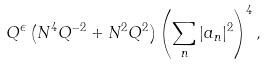Convert formula to latex. <formula><loc_0><loc_0><loc_500><loc_500>Q ^ { \epsilon } \left ( N ^ { 4 } Q ^ { - 2 } + N ^ { 2 } Q ^ { 2 } \right ) \left ( \sum _ { n } | a _ { n } | ^ { 2 } \right ) ^ { 4 } ,</formula> 